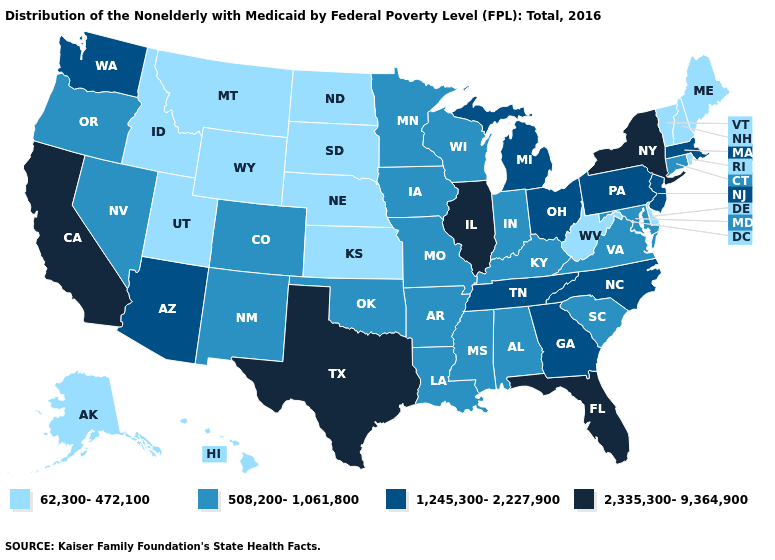What is the lowest value in states that border Montana?
Quick response, please. 62,300-472,100. Name the states that have a value in the range 1,245,300-2,227,900?
Keep it brief. Arizona, Georgia, Massachusetts, Michigan, New Jersey, North Carolina, Ohio, Pennsylvania, Tennessee, Washington. Among the states that border New York , which have the lowest value?
Keep it brief. Vermont. Which states hav the highest value in the West?
Keep it brief. California. What is the lowest value in the USA?
Short answer required. 62,300-472,100. What is the value of Wyoming?
Answer briefly. 62,300-472,100. What is the value of Delaware?
Answer briefly. 62,300-472,100. Among the states that border New Hampshire , does Vermont have the lowest value?
Write a very short answer. Yes. Name the states that have a value in the range 508,200-1,061,800?
Give a very brief answer. Alabama, Arkansas, Colorado, Connecticut, Indiana, Iowa, Kentucky, Louisiana, Maryland, Minnesota, Mississippi, Missouri, Nevada, New Mexico, Oklahoma, Oregon, South Carolina, Virginia, Wisconsin. Name the states that have a value in the range 1,245,300-2,227,900?
Be succinct. Arizona, Georgia, Massachusetts, Michigan, New Jersey, North Carolina, Ohio, Pennsylvania, Tennessee, Washington. What is the lowest value in states that border Wisconsin?
Write a very short answer. 508,200-1,061,800. Name the states that have a value in the range 62,300-472,100?
Answer briefly. Alaska, Delaware, Hawaii, Idaho, Kansas, Maine, Montana, Nebraska, New Hampshire, North Dakota, Rhode Island, South Dakota, Utah, Vermont, West Virginia, Wyoming. Is the legend a continuous bar?
Answer briefly. No. Name the states that have a value in the range 62,300-472,100?
Quick response, please. Alaska, Delaware, Hawaii, Idaho, Kansas, Maine, Montana, Nebraska, New Hampshire, North Dakota, Rhode Island, South Dakota, Utah, Vermont, West Virginia, Wyoming. Is the legend a continuous bar?
Keep it brief. No. 